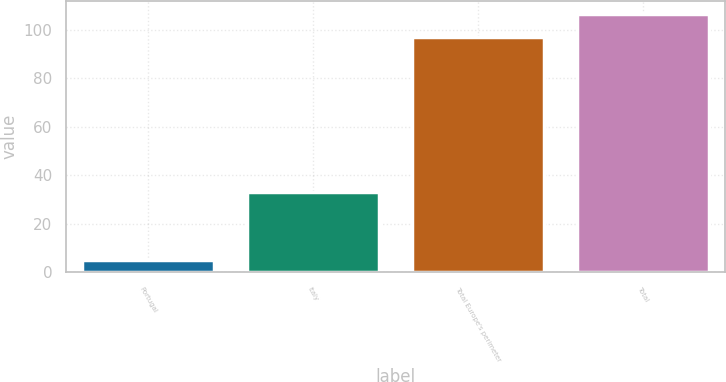<chart> <loc_0><loc_0><loc_500><loc_500><bar_chart><fcel>Portugal<fcel>Italy<fcel>Total Europe's perimeter<fcel>Total<nl><fcel>5<fcel>33<fcel>97<fcel>106.5<nl></chart> 